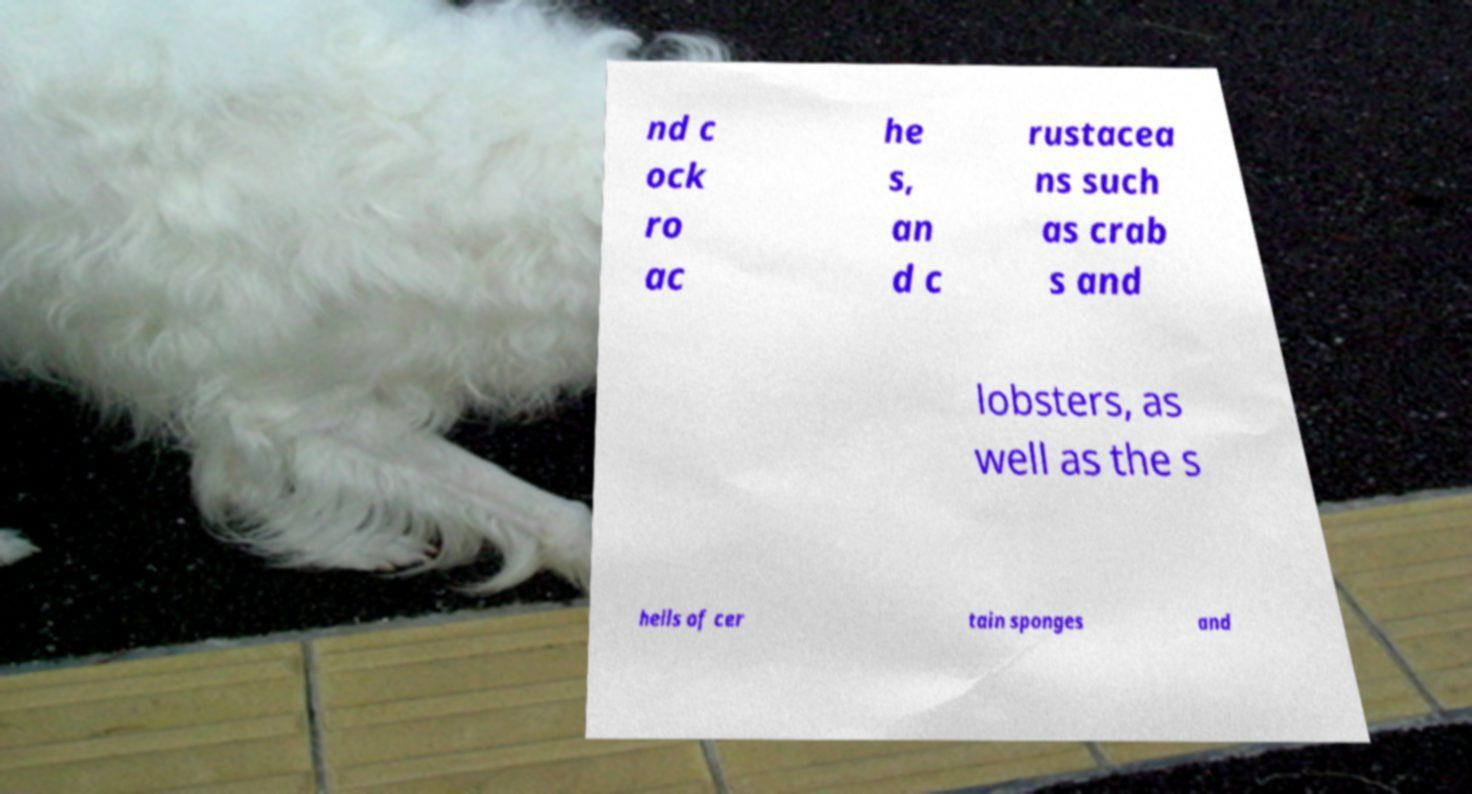Could you extract and type out the text from this image? nd c ock ro ac he s, an d c rustacea ns such as crab s and lobsters, as well as the s hells of cer tain sponges and 